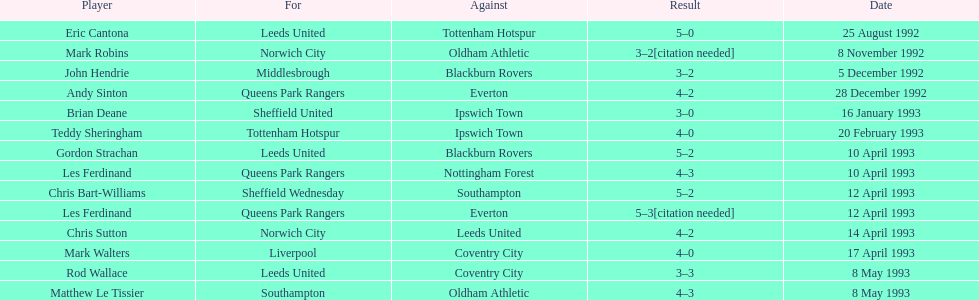Who are the participants in the 1992-93 fa premier league? Eric Cantona, Mark Robins, John Hendrie, Andy Sinton, Brian Deane, Teddy Sheringham, Gordon Strachan, Les Ferdinand, Chris Bart-Williams, Les Ferdinand, Chris Sutton, Mark Walters, Rod Wallace, Matthew Le Tissier. Can you give me this table as a dict? {'header': ['Player', 'For', 'Against', 'Result', 'Date'], 'rows': [['Eric Cantona', 'Leeds United', 'Tottenham Hotspur', '5–0', '25 August 1992'], ['Mark Robins', 'Norwich City', 'Oldham Athletic', '3–2[citation needed]', '8 November 1992'], ['John Hendrie', 'Middlesbrough', 'Blackburn Rovers', '3–2', '5 December 1992'], ['Andy Sinton', 'Queens Park Rangers', 'Everton', '4–2', '28 December 1992'], ['Brian Deane', 'Sheffield United', 'Ipswich Town', '3–0', '16 January 1993'], ['Teddy Sheringham', 'Tottenham Hotspur', 'Ipswich Town', '4–0', '20 February 1993'], ['Gordon Strachan', 'Leeds United', 'Blackburn Rovers', '5–2', '10 April 1993'], ['Les Ferdinand', 'Queens Park Rangers', 'Nottingham Forest', '4–3', '10 April 1993'], ['Chris Bart-Williams', 'Sheffield Wednesday', 'Southampton', '5–2', '12 April 1993'], ['Les Ferdinand', 'Queens Park Rangers', 'Everton', '5–3[citation needed]', '12 April 1993'], ['Chris Sutton', 'Norwich City', 'Leeds United', '4–2', '14 April 1993'], ['Mark Walters', 'Liverpool', 'Coventry City', '4–0', '17 April 1993'], ['Rod Wallace', 'Leeds United', 'Coventry City', '3–3', '8 May 1993'], ['Matthew Le Tissier', 'Southampton', 'Oldham Athletic', '4–3', '8 May 1993']]} What is mark robins' outcome? 3–2[citation needed]. Which player has an identical outcome? John Hendrie. 